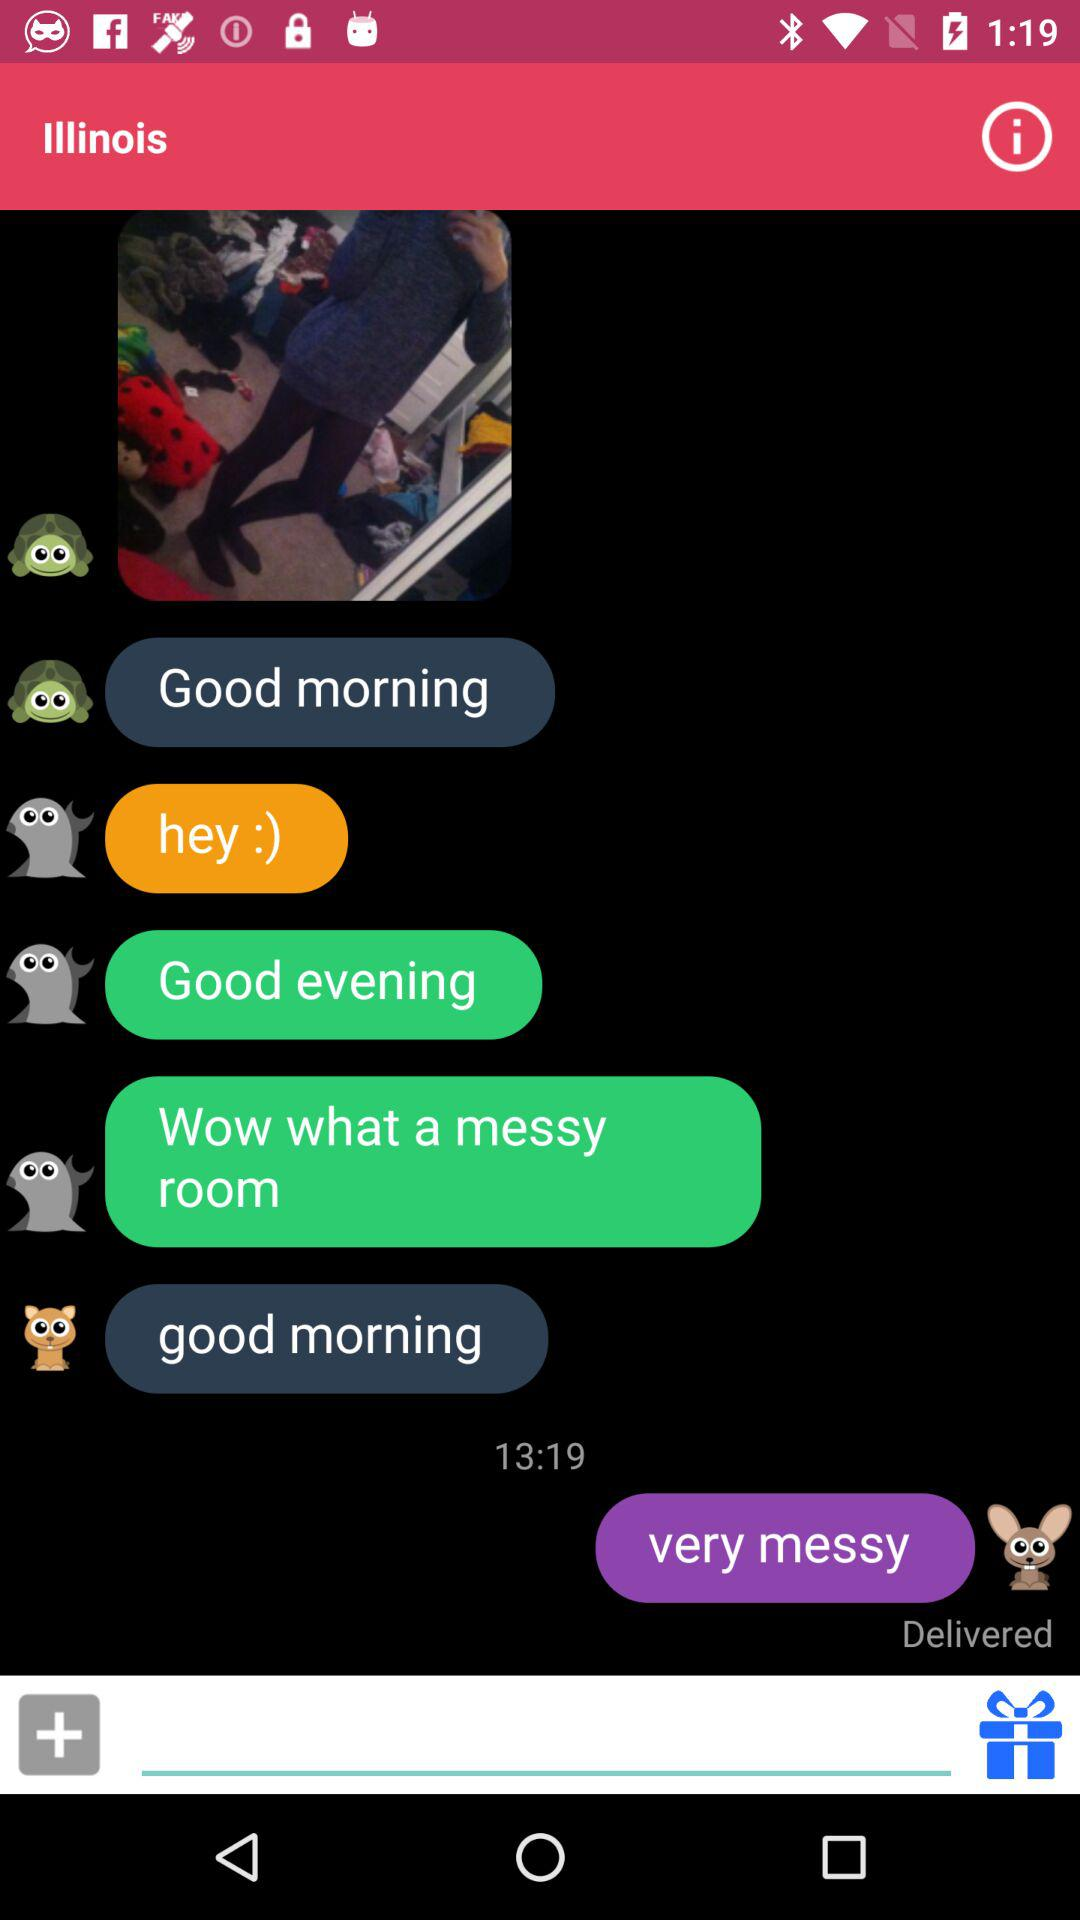Is the last message delivered or undelivered? The last message is delivered. 